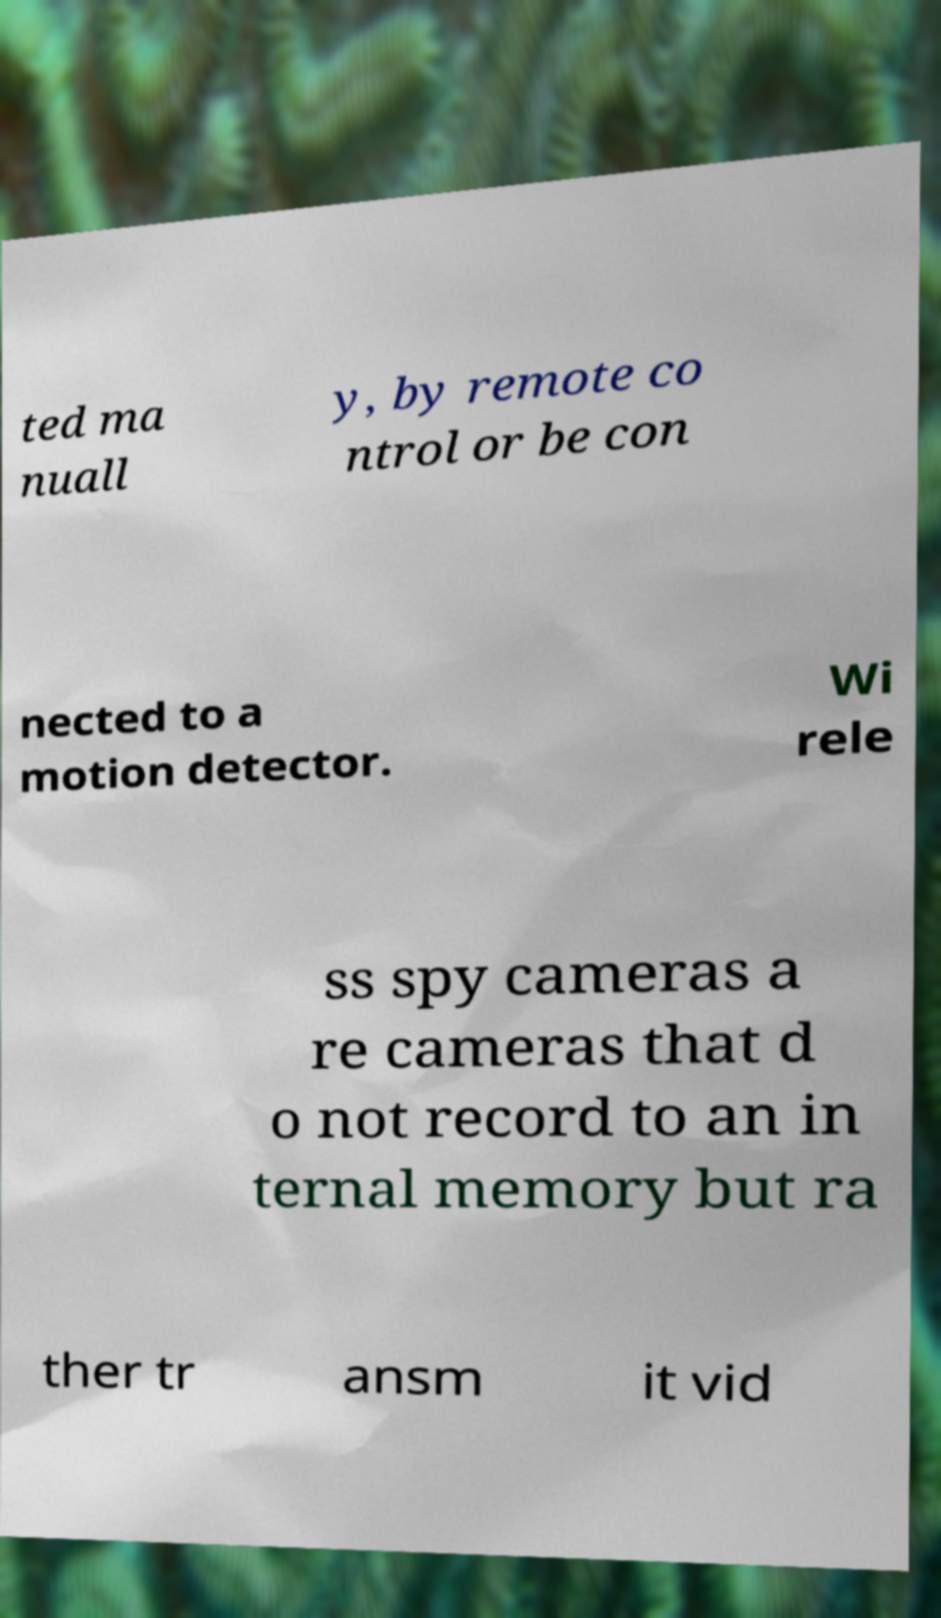There's text embedded in this image that I need extracted. Can you transcribe it verbatim? ted ma nuall y, by remote co ntrol or be con nected to a motion detector. Wi rele ss spy cameras a re cameras that d o not record to an in ternal memory but ra ther tr ansm it vid 